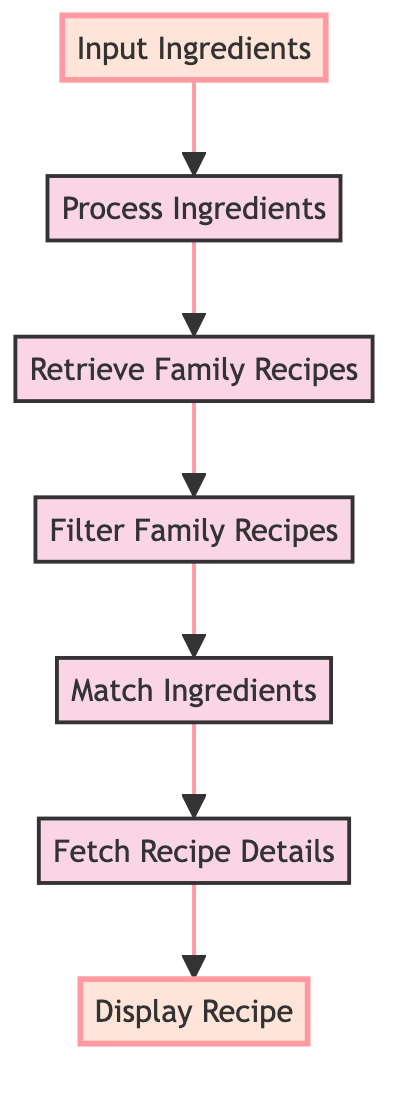What is the first step in the cooking recipe recommender? The first step is "Input Ingredients", where the user enters the ingredients they have at home.
Answer: Input Ingredients What step comes after "Process Ingredients"? The step that comes after "Process Ingredients" is "Retrieve Family Recipes".
Answer: Retrieve Family Recipes How many total steps are in the flowchart? There are six steps in the flowchart: Input Ingredients, Process Ingredients, Retrieve Family Recipes, Filter Family Recipes, Match Ingredients, Fetch Recipe Details, and Display Recipe.
Answer: Six Which step displays the final output? The final output is displayed in the step called "Display Recipe".
Answer: Display Recipe What is the relationship between "Match Ingredients" and "Fetch Recipe Details"? "Match Ingredients" must complete before "Fetch Recipe Details" can take place; it relies on successfully matching available ingredients.
Answer: Match Ingredients leads to Fetch Recipe Details What comes before "Filter Family Recipes"? The step that comes before "Filter Family Recipes" is "Retrieve Family Recipes".
Answer: Retrieve Family Recipes What is the role of "Process Ingredients"? "Process Ingredients" simplifies entered ingredients to ensure they match the format used in the recipe database.
Answer: Simplify ingredients Which element connects "Display Recipe" to the previous step? "Fetch Recipe Details" connects "Display Recipe" to the previous step in the flowchart.
Answer: Fetch Recipe Details What do you do after entering ingredients? After entering ingredients, you "Process Ingredients" next in the flowchart.
Answer: Process Ingredients Which step filters out recipes? The step that filters out recipes is called "Filter Family Recipes".
Answer: Filter Family Recipes 